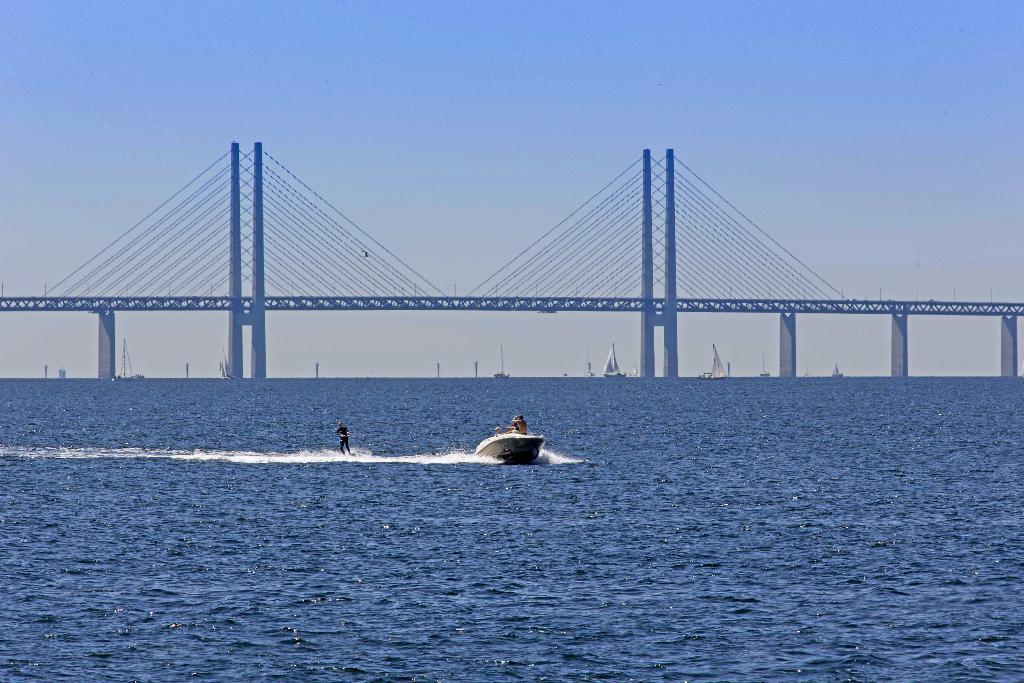How would you summarize this image in a sentence or two? In this image we can see the bridge with the ropes. We can also see the ships and also the persons boating. There is also a man surfing on the surface of the water. In the background, we can see the sky. 